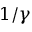Convert formula to latex. <formula><loc_0><loc_0><loc_500><loc_500>1 / \gamma</formula> 